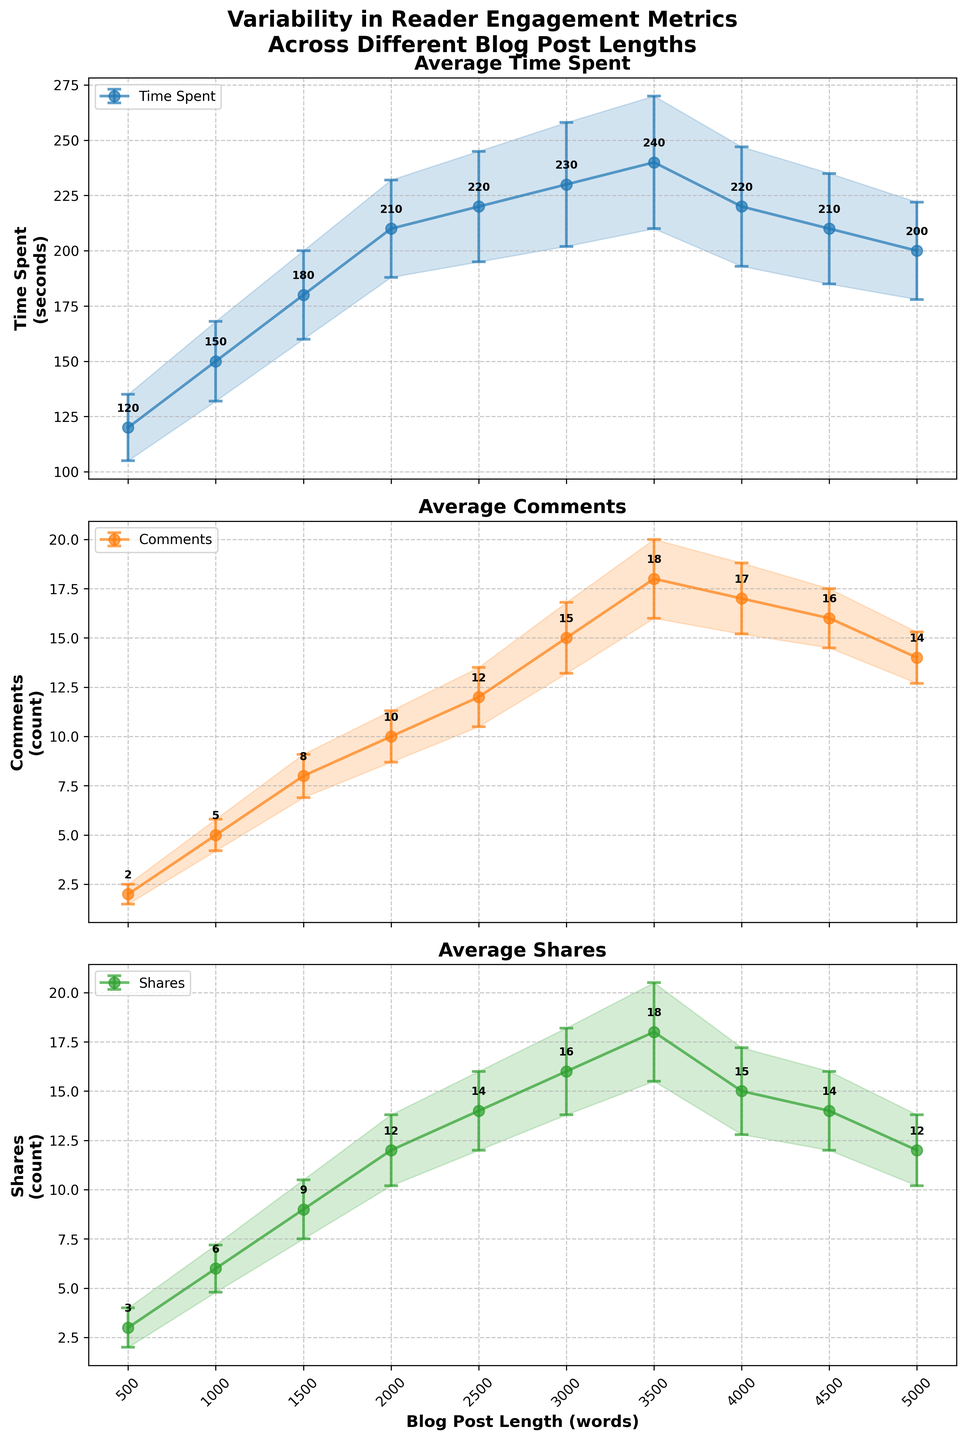What is the title of the figure? The title of the figure is displayed at the top, written in bold font. It reads "Variability in Reader Engagement Metrics Across Different Blog Post Lengths."
Answer: Variability in Reader Engagement Metrics Across Different Blog Post Lengths What is the longest blog post length shown in the figure? The x-axis represents the blog post lengths, and the longest blog post length marked on the x-axis is 5000 words.
Answer: 5000 words Which blog post length has the highest average number of comments? Observing the subplot titled 'Average Comments,' the highest point is at a blog post length of 3500 words with an average of 18 comments.
Answer: 3500 words Between which blog post lengths does the average time spent by readers peak? The subplot titled 'Average Time Spent' shows the highest average reading time occurs at blog post lengths between 3000 and 4000 words, peaking exactly at 3500 words.
Answer: Between 3000 and 4000 words How does the average number of shares change from a post length of 2000 to 3000 words? Looking at the 'Average Shares' subplot, the number of shares increases from 12 shares at 2000 words to 16 shares at 3000 words.
Answer: Increases What is the overall trend in average time spent as the blog post length increases from 500 to 3000 words? The subplot titled 'Average Time Spent' shows an increasing trend in average time spent, starting at 120 seconds for 500 words and peaking at 230 seconds for 3000 words.
Answer: Increasing Which blog post length has the least variability in average comments? Examining the error bars in the subplot titled 'Average Comments,' the post length of 500 words has the smallest error bar, indicating the least variability.
Answer: 500 words How does the average number of comments for a 4500-word blog post compare to a 1500-word blog post? The 'Average Comments' subplot shows that a 4500-word blog post has 16 comments on average, while a 1500-word post has 8 comments. Thus, a 4500-word post has more comments than a 1500-word post.
Answer: 4500-word has more comments What is the average time spent on blog posts of 4000 and 4500 words, and how do they compare? The 'Average Time Spent' subplot shows that the average time is 220 seconds for 4000-word blog posts and 210 seconds for 4500-word posts. The difference is 220 - 210 = 10 seconds.
Answer: 4000-word posts have 10 seconds more At what blog post length does the average number of shares start to decline? Observing the 'Average Shares' subplot, the number of shares peaks at 3500 words and starts to decline beyond this length.
Answer: 3500 words 